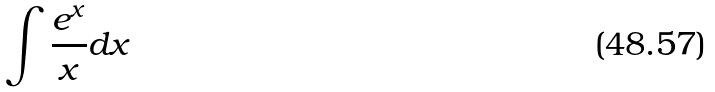Convert formula to latex. <formula><loc_0><loc_0><loc_500><loc_500>\int \frac { e ^ { x } } { x } d x</formula> 